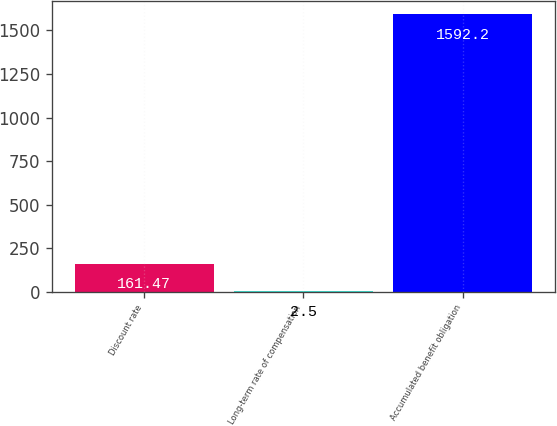Convert chart to OTSL. <chart><loc_0><loc_0><loc_500><loc_500><bar_chart><fcel>Discount rate<fcel>Long-term rate of compensation<fcel>Accumulated benefit obligation<nl><fcel>161.47<fcel>2.5<fcel>1592.2<nl></chart> 